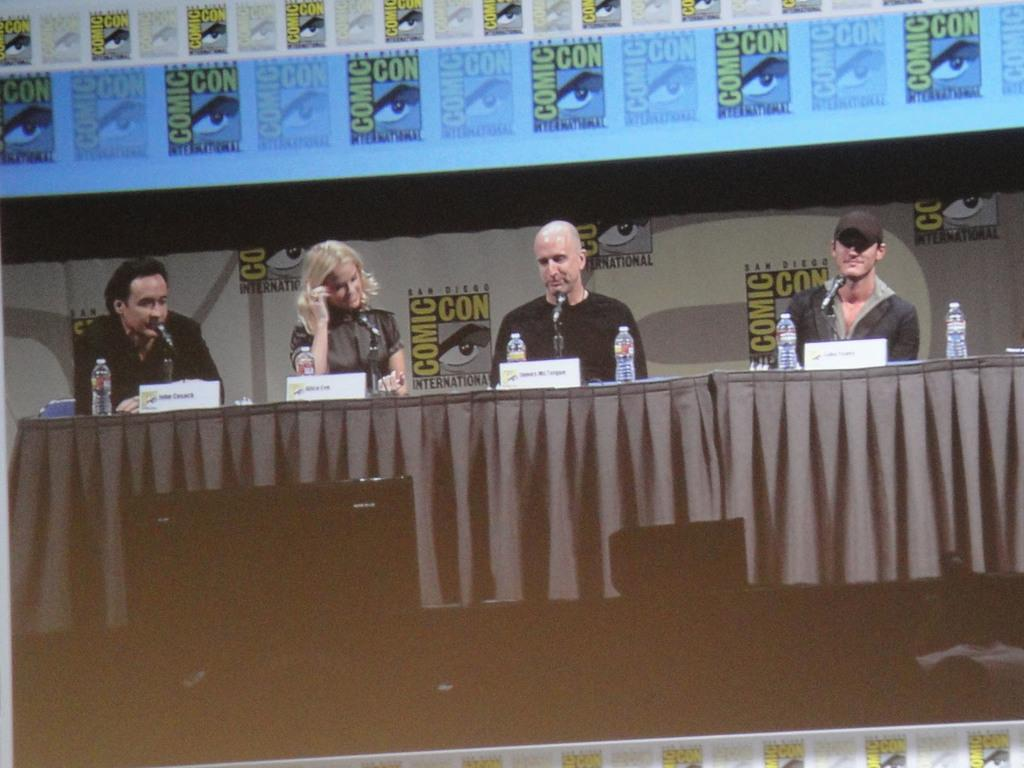How many people are present in the image? There are four people in the image. What is placed in front of the people? There is a tablecloth, microphones, bottles, name boards, a monitor, and some objects in front of the people. What can be seen in the background of the image? There are banners in the background of the image. What is the condition of the banana on the table in the image? There is no banana present in the image. How far away are the people from the camera in the image? The distance of the people from the camera cannot be determined from the image alone. 